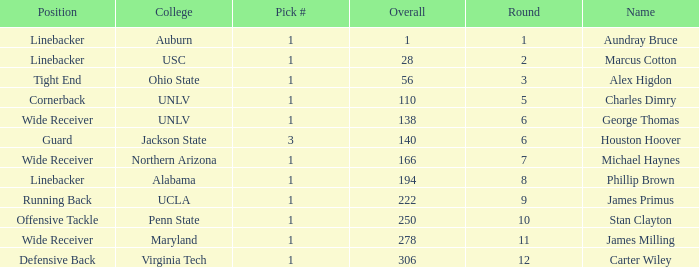In what Round was George Thomas Picked? 6.0. 